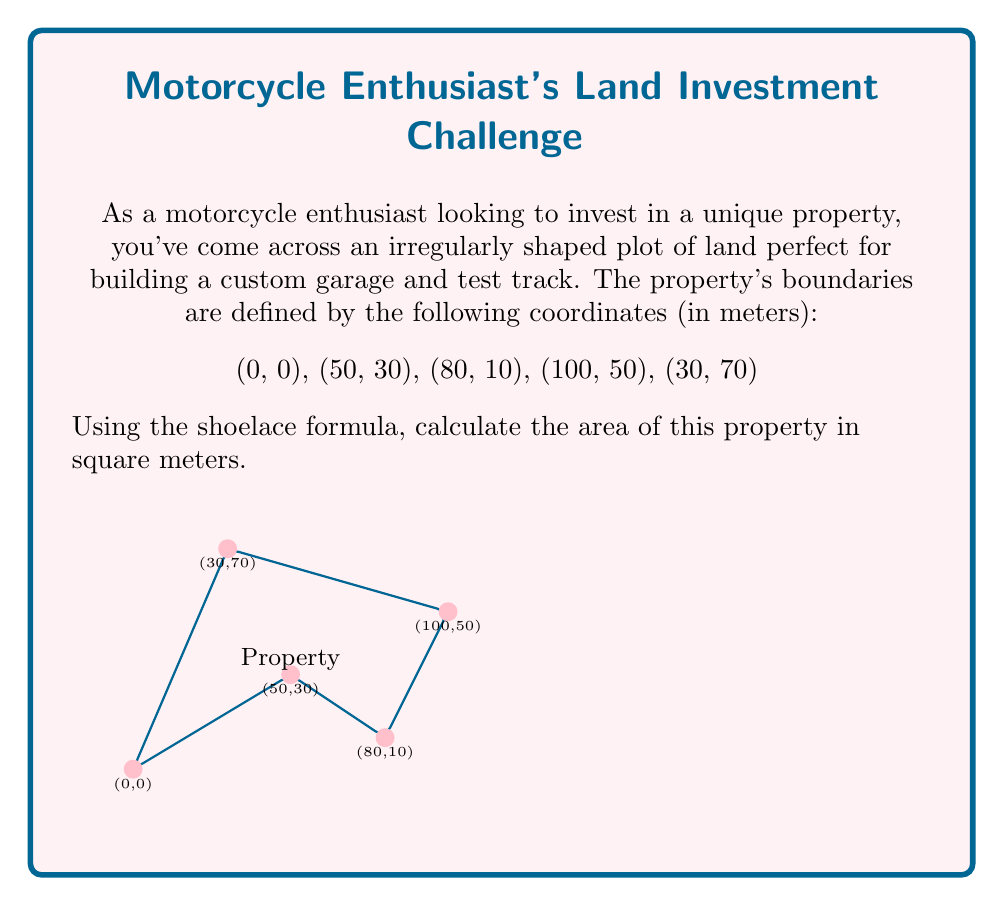Could you help me with this problem? To solve this problem, we'll use the shoelace formula, also known as the surveyor's formula. The formula calculates the area of a polygon given its vertices.

Step 1: List the coordinates in order.
$$(x_1, y_1) = (0, 0)$$
$$(x_2, y_2) = (50, 30)$$
$$(x_3, y_3) = (80, 10)$$
$$(x_4, y_4) = (100, 50)$$
$$(x_5, y_5) = (30, 70)$$

Step 2: Apply the shoelace formula:
$$A = \frac{1}{2}|(x_1y_2 + x_2y_3 + x_3y_4 + x_4y_5 + x_5y_1) - (y_1x_2 + y_2x_3 + y_3x_4 + y_4x_5 + y_5x_1)|$$

Step 3: Substitute the values:
$$A = \frac{1}{2}|(0 \cdot 30 + 50 \cdot 10 + 80 \cdot 50 + 100 \cdot 70 + 30 \cdot 0) - (0 \cdot 50 + 30 \cdot 80 + 10 \cdot 100 + 50 \cdot 30 + 70 \cdot 0)|$$

Step 4: Calculate the products:
$$A = \frac{1}{2}|(0 + 500 + 4000 + 7000 + 0) - (0 + 2400 + 1000 + 1500 + 0)|$$

Step 5: Sum the terms:
$$A = \frac{1}{2}|11500 - 4900|$$

Step 6: Calculate the final result:
$$A = \frac{1}{2} \cdot 6600 = 3300$$

Therefore, the area of the property is 3300 square meters.
Answer: 3300 m² 